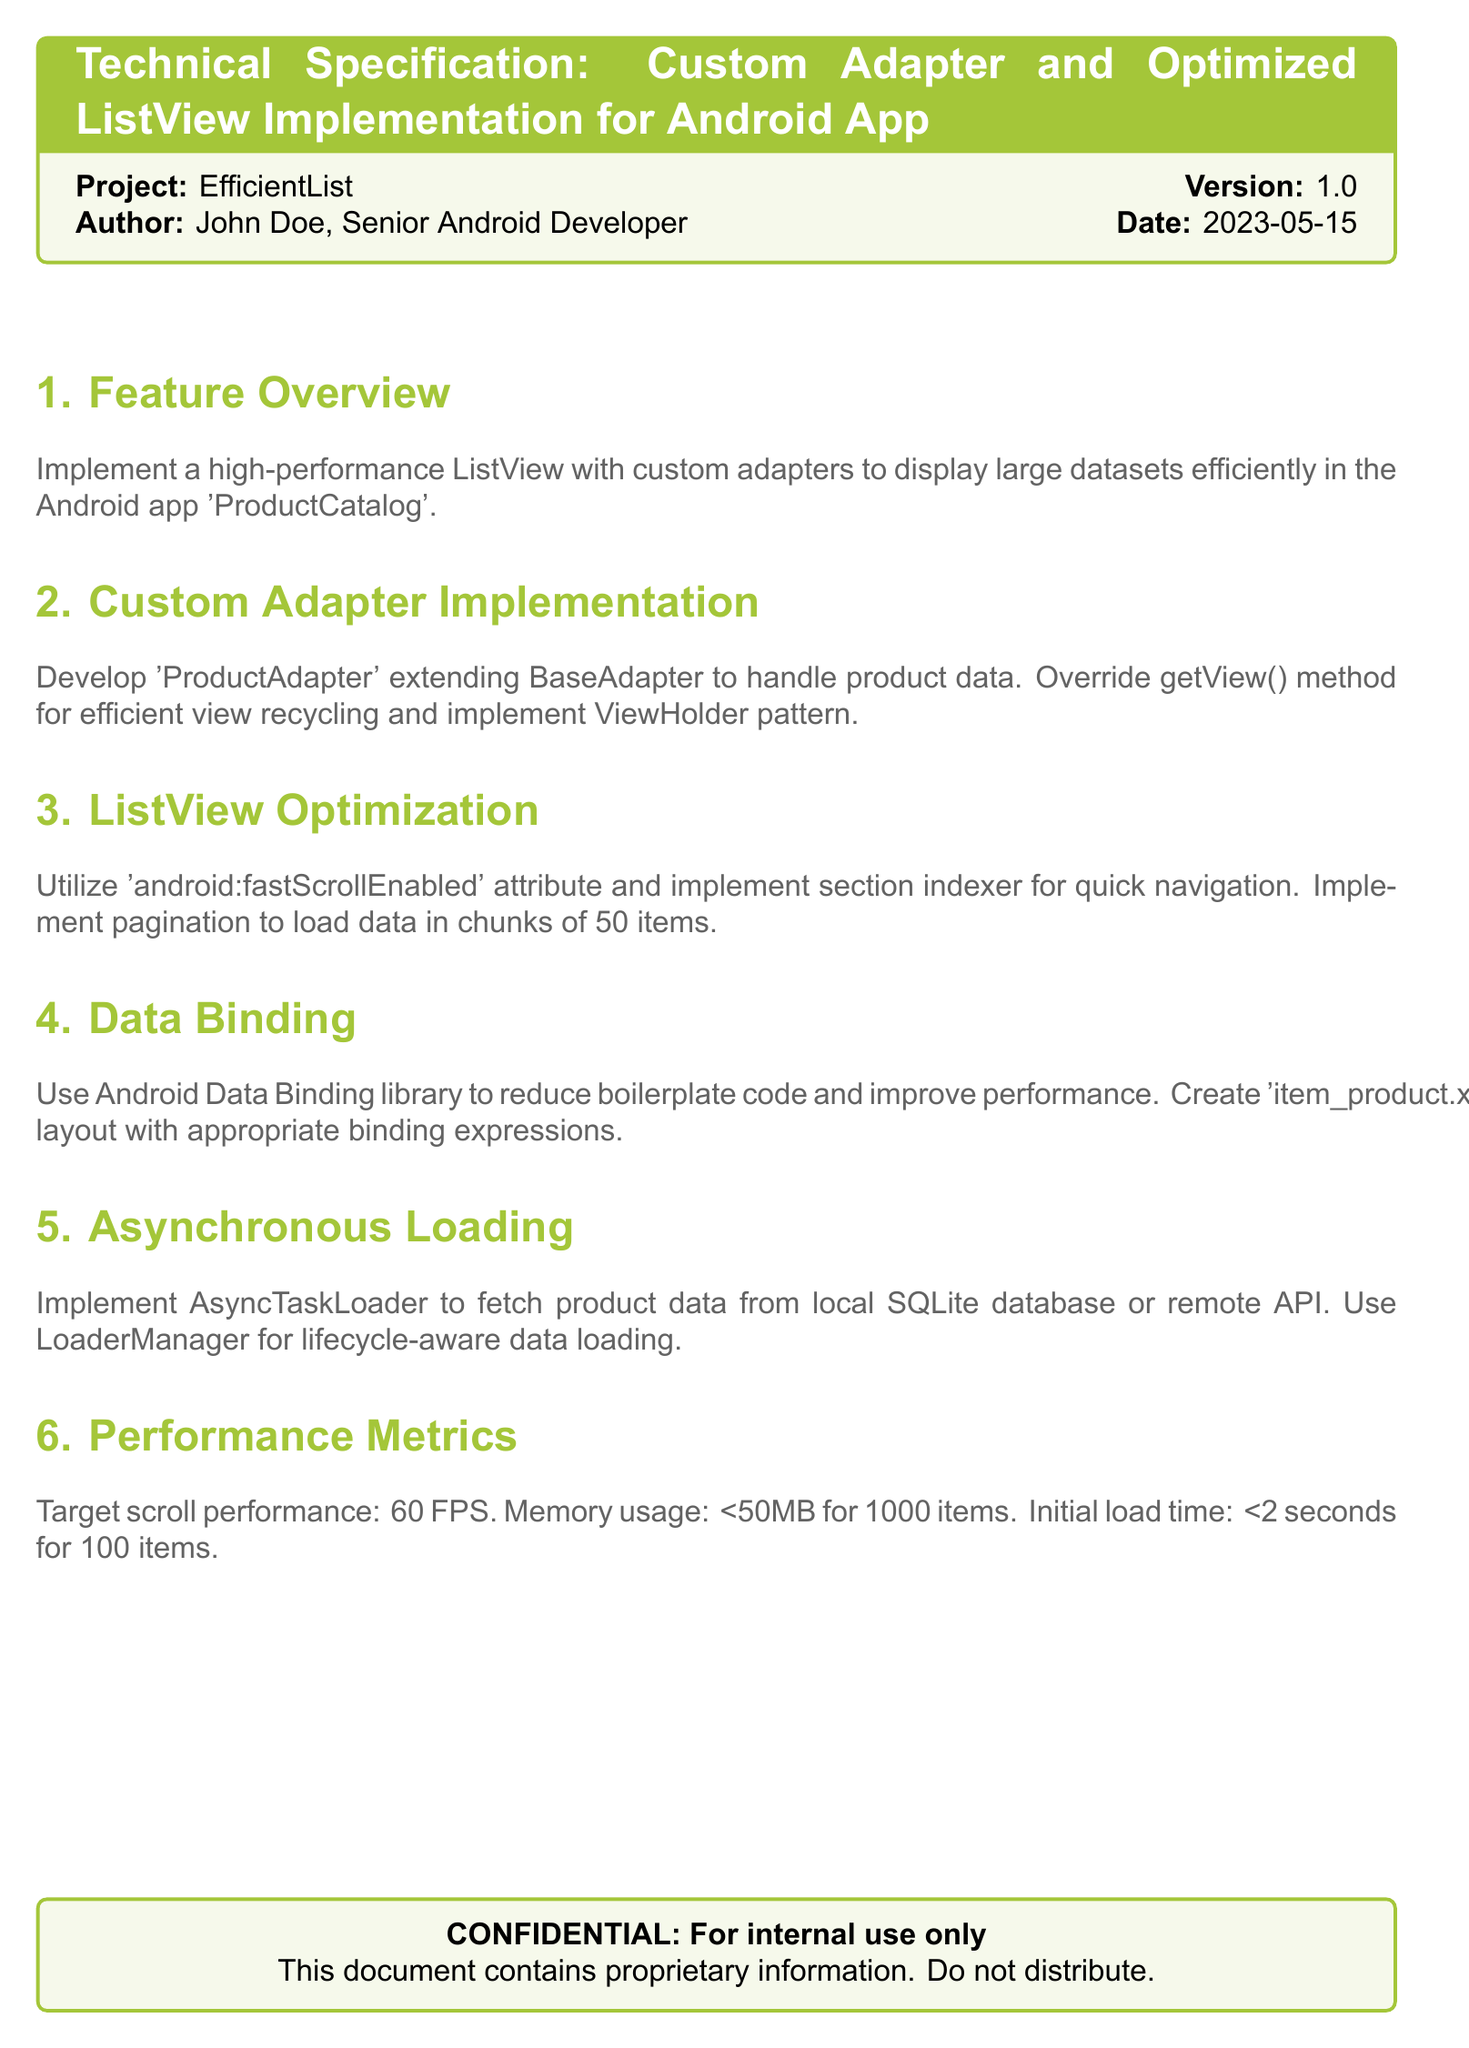What is the project name? The project name is stated in the document as part of the title information.
Answer: EfficientList Who is the author of the document? The author is mentioned under the project details.
Answer: John Doe What is the version of the project? The version is found in the project title information.
Answer: 1.0 What is the target scroll performance? This information is provided under the performance metrics section of the document.
Answer: 60 FPS How many items does pagination load at a time? The specific quantity for pagination is specified in the ListView optimization section.
Answer: 50 items What layout file is created for binding expressions? The layout file is mentioned as part of the data binding section.
Answer: item_product.xml When was the document created? The date of creation is provided in the document for reference.
Answer: 2023-05-15 What memory usage target is mentioned for 1000 items? This target is included in the performance metrics section.
Answer: <50MB What asynchronous loading class is implemented? The class name is identified in the asynchronous loading section of the document.
Answer: AsyncTaskLoader 